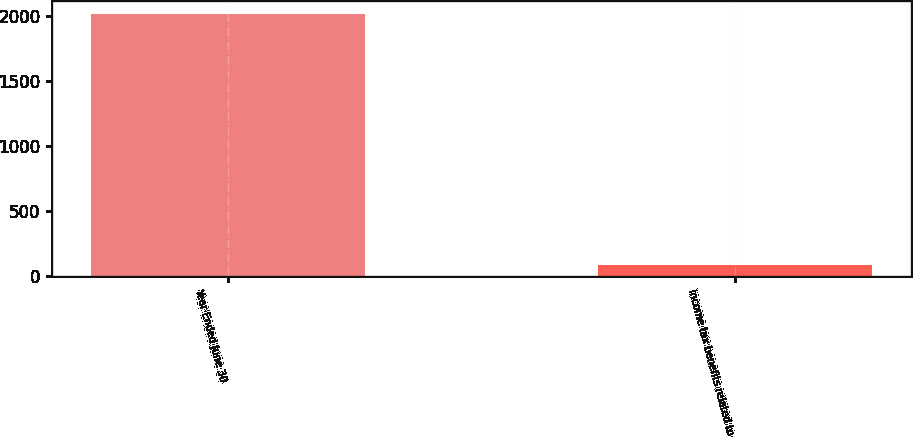Convert chart to OTSL. <chart><loc_0><loc_0><loc_500><loc_500><bar_chart><fcel>Year Ended June 30<fcel>Income tax benefits related to<nl><fcel>2015<fcel>86<nl></chart> 